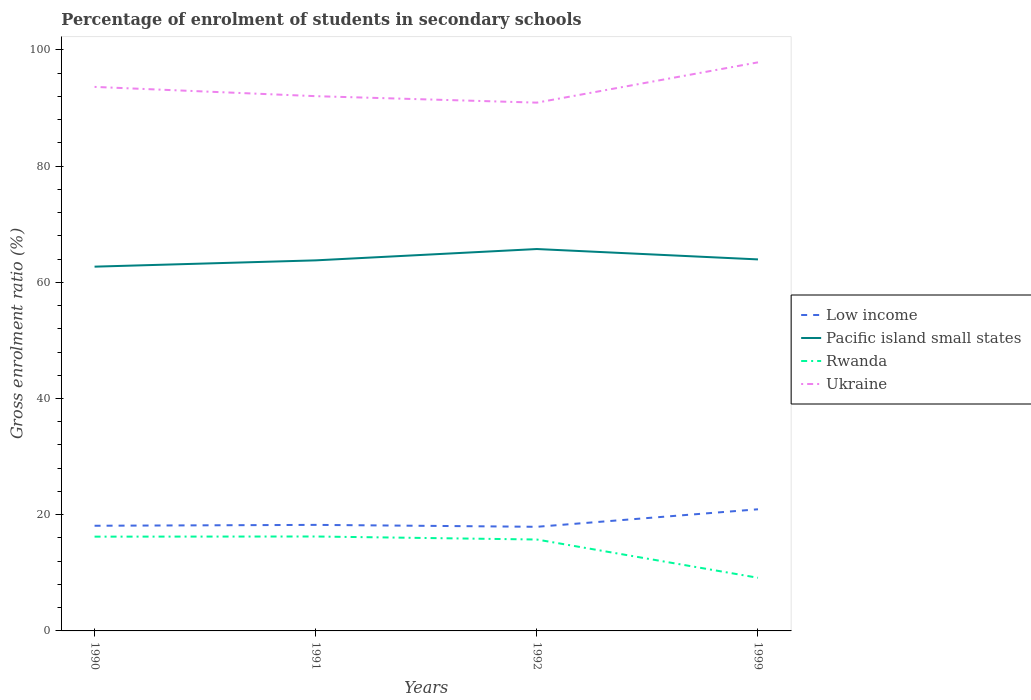How many different coloured lines are there?
Make the answer very short. 4. Does the line corresponding to Rwanda intersect with the line corresponding to Low income?
Provide a succinct answer. No. Is the number of lines equal to the number of legend labels?
Ensure brevity in your answer.  Yes. Across all years, what is the maximum percentage of students enrolled in secondary schools in Rwanda?
Your answer should be compact. 9.15. In which year was the percentage of students enrolled in secondary schools in Low income maximum?
Offer a terse response. 1992. What is the total percentage of students enrolled in secondary schools in Ukraine in the graph?
Keep it short and to the point. -5.82. What is the difference between the highest and the second highest percentage of students enrolled in secondary schools in Low income?
Offer a terse response. 3.02. How many lines are there?
Offer a very short reply. 4. Are the values on the major ticks of Y-axis written in scientific E-notation?
Ensure brevity in your answer.  No. Does the graph contain any zero values?
Your answer should be very brief. No. Does the graph contain grids?
Ensure brevity in your answer.  No. Where does the legend appear in the graph?
Keep it short and to the point. Center right. How many legend labels are there?
Make the answer very short. 4. What is the title of the graph?
Give a very brief answer. Percentage of enrolment of students in secondary schools. Does "Venezuela" appear as one of the legend labels in the graph?
Provide a succinct answer. No. What is the label or title of the Y-axis?
Give a very brief answer. Gross enrolment ratio (%). What is the Gross enrolment ratio (%) in Low income in 1990?
Keep it short and to the point. 18.1. What is the Gross enrolment ratio (%) in Pacific island small states in 1990?
Provide a succinct answer. 62.69. What is the Gross enrolment ratio (%) in Rwanda in 1990?
Make the answer very short. 16.23. What is the Gross enrolment ratio (%) in Ukraine in 1990?
Your answer should be compact. 93.63. What is the Gross enrolment ratio (%) of Low income in 1991?
Make the answer very short. 18.25. What is the Gross enrolment ratio (%) in Pacific island small states in 1991?
Give a very brief answer. 63.78. What is the Gross enrolment ratio (%) in Rwanda in 1991?
Provide a short and direct response. 16.25. What is the Gross enrolment ratio (%) of Ukraine in 1991?
Your answer should be very brief. 92.04. What is the Gross enrolment ratio (%) in Low income in 1992?
Your answer should be compact. 17.92. What is the Gross enrolment ratio (%) of Pacific island small states in 1992?
Your response must be concise. 65.73. What is the Gross enrolment ratio (%) in Rwanda in 1992?
Give a very brief answer. 15.73. What is the Gross enrolment ratio (%) in Ukraine in 1992?
Ensure brevity in your answer.  90.92. What is the Gross enrolment ratio (%) in Low income in 1999?
Ensure brevity in your answer.  20.94. What is the Gross enrolment ratio (%) of Pacific island small states in 1999?
Offer a terse response. 63.94. What is the Gross enrolment ratio (%) in Rwanda in 1999?
Your response must be concise. 9.15. What is the Gross enrolment ratio (%) in Ukraine in 1999?
Make the answer very short. 97.86. Across all years, what is the maximum Gross enrolment ratio (%) of Low income?
Your response must be concise. 20.94. Across all years, what is the maximum Gross enrolment ratio (%) of Pacific island small states?
Your response must be concise. 65.73. Across all years, what is the maximum Gross enrolment ratio (%) of Rwanda?
Your response must be concise. 16.25. Across all years, what is the maximum Gross enrolment ratio (%) in Ukraine?
Offer a terse response. 97.86. Across all years, what is the minimum Gross enrolment ratio (%) in Low income?
Your response must be concise. 17.92. Across all years, what is the minimum Gross enrolment ratio (%) of Pacific island small states?
Your response must be concise. 62.69. Across all years, what is the minimum Gross enrolment ratio (%) of Rwanda?
Your answer should be very brief. 9.15. Across all years, what is the minimum Gross enrolment ratio (%) in Ukraine?
Your answer should be compact. 90.92. What is the total Gross enrolment ratio (%) of Low income in the graph?
Your response must be concise. 75.21. What is the total Gross enrolment ratio (%) in Pacific island small states in the graph?
Make the answer very short. 256.14. What is the total Gross enrolment ratio (%) of Rwanda in the graph?
Offer a terse response. 57.36. What is the total Gross enrolment ratio (%) in Ukraine in the graph?
Your answer should be very brief. 374.45. What is the difference between the Gross enrolment ratio (%) in Low income in 1990 and that in 1991?
Your response must be concise. -0.15. What is the difference between the Gross enrolment ratio (%) in Pacific island small states in 1990 and that in 1991?
Offer a terse response. -1.08. What is the difference between the Gross enrolment ratio (%) of Rwanda in 1990 and that in 1991?
Your response must be concise. -0.03. What is the difference between the Gross enrolment ratio (%) in Ukraine in 1990 and that in 1991?
Give a very brief answer. 1.6. What is the difference between the Gross enrolment ratio (%) of Low income in 1990 and that in 1992?
Your answer should be very brief. 0.18. What is the difference between the Gross enrolment ratio (%) of Pacific island small states in 1990 and that in 1992?
Ensure brevity in your answer.  -3.03. What is the difference between the Gross enrolment ratio (%) in Rwanda in 1990 and that in 1992?
Give a very brief answer. 0.49. What is the difference between the Gross enrolment ratio (%) of Ukraine in 1990 and that in 1992?
Keep it short and to the point. 2.71. What is the difference between the Gross enrolment ratio (%) in Low income in 1990 and that in 1999?
Ensure brevity in your answer.  -2.84. What is the difference between the Gross enrolment ratio (%) of Pacific island small states in 1990 and that in 1999?
Make the answer very short. -1.25. What is the difference between the Gross enrolment ratio (%) of Rwanda in 1990 and that in 1999?
Ensure brevity in your answer.  7.08. What is the difference between the Gross enrolment ratio (%) in Ukraine in 1990 and that in 1999?
Your answer should be compact. -4.22. What is the difference between the Gross enrolment ratio (%) in Low income in 1991 and that in 1992?
Provide a succinct answer. 0.33. What is the difference between the Gross enrolment ratio (%) of Pacific island small states in 1991 and that in 1992?
Give a very brief answer. -1.95. What is the difference between the Gross enrolment ratio (%) in Rwanda in 1991 and that in 1992?
Your answer should be very brief. 0.52. What is the difference between the Gross enrolment ratio (%) of Ukraine in 1991 and that in 1992?
Provide a short and direct response. 1.11. What is the difference between the Gross enrolment ratio (%) of Low income in 1991 and that in 1999?
Offer a terse response. -2.69. What is the difference between the Gross enrolment ratio (%) in Pacific island small states in 1991 and that in 1999?
Offer a very short reply. -0.17. What is the difference between the Gross enrolment ratio (%) of Rwanda in 1991 and that in 1999?
Provide a succinct answer. 7.11. What is the difference between the Gross enrolment ratio (%) in Ukraine in 1991 and that in 1999?
Provide a succinct answer. -5.82. What is the difference between the Gross enrolment ratio (%) of Low income in 1992 and that in 1999?
Your answer should be compact. -3.02. What is the difference between the Gross enrolment ratio (%) of Pacific island small states in 1992 and that in 1999?
Offer a very short reply. 1.78. What is the difference between the Gross enrolment ratio (%) in Rwanda in 1992 and that in 1999?
Provide a short and direct response. 6.58. What is the difference between the Gross enrolment ratio (%) of Ukraine in 1992 and that in 1999?
Offer a terse response. -6.93. What is the difference between the Gross enrolment ratio (%) of Low income in 1990 and the Gross enrolment ratio (%) of Pacific island small states in 1991?
Ensure brevity in your answer.  -45.68. What is the difference between the Gross enrolment ratio (%) in Low income in 1990 and the Gross enrolment ratio (%) in Rwanda in 1991?
Offer a very short reply. 1.85. What is the difference between the Gross enrolment ratio (%) in Low income in 1990 and the Gross enrolment ratio (%) in Ukraine in 1991?
Keep it short and to the point. -73.94. What is the difference between the Gross enrolment ratio (%) of Pacific island small states in 1990 and the Gross enrolment ratio (%) of Rwanda in 1991?
Give a very brief answer. 46.44. What is the difference between the Gross enrolment ratio (%) in Pacific island small states in 1990 and the Gross enrolment ratio (%) in Ukraine in 1991?
Provide a succinct answer. -29.34. What is the difference between the Gross enrolment ratio (%) in Rwanda in 1990 and the Gross enrolment ratio (%) in Ukraine in 1991?
Make the answer very short. -75.81. What is the difference between the Gross enrolment ratio (%) of Low income in 1990 and the Gross enrolment ratio (%) of Pacific island small states in 1992?
Your response must be concise. -47.63. What is the difference between the Gross enrolment ratio (%) in Low income in 1990 and the Gross enrolment ratio (%) in Rwanda in 1992?
Give a very brief answer. 2.37. What is the difference between the Gross enrolment ratio (%) in Low income in 1990 and the Gross enrolment ratio (%) in Ukraine in 1992?
Make the answer very short. -72.82. What is the difference between the Gross enrolment ratio (%) of Pacific island small states in 1990 and the Gross enrolment ratio (%) of Rwanda in 1992?
Keep it short and to the point. 46.96. What is the difference between the Gross enrolment ratio (%) of Pacific island small states in 1990 and the Gross enrolment ratio (%) of Ukraine in 1992?
Keep it short and to the point. -28.23. What is the difference between the Gross enrolment ratio (%) in Rwanda in 1990 and the Gross enrolment ratio (%) in Ukraine in 1992?
Your answer should be compact. -74.7. What is the difference between the Gross enrolment ratio (%) in Low income in 1990 and the Gross enrolment ratio (%) in Pacific island small states in 1999?
Keep it short and to the point. -45.84. What is the difference between the Gross enrolment ratio (%) in Low income in 1990 and the Gross enrolment ratio (%) in Rwanda in 1999?
Your response must be concise. 8.95. What is the difference between the Gross enrolment ratio (%) in Low income in 1990 and the Gross enrolment ratio (%) in Ukraine in 1999?
Keep it short and to the point. -79.76. What is the difference between the Gross enrolment ratio (%) of Pacific island small states in 1990 and the Gross enrolment ratio (%) of Rwanda in 1999?
Your answer should be very brief. 53.55. What is the difference between the Gross enrolment ratio (%) in Pacific island small states in 1990 and the Gross enrolment ratio (%) in Ukraine in 1999?
Give a very brief answer. -35.16. What is the difference between the Gross enrolment ratio (%) in Rwanda in 1990 and the Gross enrolment ratio (%) in Ukraine in 1999?
Provide a short and direct response. -81.63. What is the difference between the Gross enrolment ratio (%) of Low income in 1991 and the Gross enrolment ratio (%) of Pacific island small states in 1992?
Give a very brief answer. -47.48. What is the difference between the Gross enrolment ratio (%) in Low income in 1991 and the Gross enrolment ratio (%) in Rwanda in 1992?
Keep it short and to the point. 2.52. What is the difference between the Gross enrolment ratio (%) of Low income in 1991 and the Gross enrolment ratio (%) of Ukraine in 1992?
Offer a terse response. -72.67. What is the difference between the Gross enrolment ratio (%) in Pacific island small states in 1991 and the Gross enrolment ratio (%) in Rwanda in 1992?
Provide a succinct answer. 48.05. What is the difference between the Gross enrolment ratio (%) of Pacific island small states in 1991 and the Gross enrolment ratio (%) of Ukraine in 1992?
Your answer should be very brief. -27.15. What is the difference between the Gross enrolment ratio (%) of Rwanda in 1991 and the Gross enrolment ratio (%) of Ukraine in 1992?
Provide a short and direct response. -74.67. What is the difference between the Gross enrolment ratio (%) of Low income in 1991 and the Gross enrolment ratio (%) of Pacific island small states in 1999?
Make the answer very short. -45.69. What is the difference between the Gross enrolment ratio (%) in Low income in 1991 and the Gross enrolment ratio (%) in Rwanda in 1999?
Make the answer very short. 9.1. What is the difference between the Gross enrolment ratio (%) in Low income in 1991 and the Gross enrolment ratio (%) in Ukraine in 1999?
Provide a short and direct response. -79.61. What is the difference between the Gross enrolment ratio (%) in Pacific island small states in 1991 and the Gross enrolment ratio (%) in Rwanda in 1999?
Provide a succinct answer. 54.63. What is the difference between the Gross enrolment ratio (%) of Pacific island small states in 1991 and the Gross enrolment ratio (%) of Ukraine in 1999?
Ensure brevity in your answer.  -34.08. What is the difference between the Gross enrolment ratio (%) in Rwanda in 1991 and the Gross enrolment ratio (%) in Ukraine in 1999?
Your answer should be very brief. -81.6. What is the difference between the Gross enrolment ratio (%) in Low income in 1992 and the Gross enrolment ratio (%) in Pacific island small states in 1999?
Keep it short and to the point. -46.02. What is the difference between the Gross enrolment ratio (%) in Low income in 1992 and the Gross enrolment ratio (%) in Rwanda in 1999?
Provide a succinct answer. 8.77. What is the difference between the Gross enrolment ratio (%) in Low income in 1992 and the Gross enrolment ratio (%) in Ukraine in 1999?
Offer a very short reply. -79.94. What is the difference between the Gross enrolment ratio (%) in Pacific island small states in 1992 and the Gross enrolment ratio (%) in Rwanda in 1999?
Provide a short and direct response. 56.58. What is the difference between the Gross enrolment ratio (%) in Pacific island small states in 1992 and the Gross enrolment ratio (%) in Ukraine in 1999?
Offer a very short reply. -32.13. What is the difference between the Gross enrolment ratio (%) in Rwanda in 1992 and the Gross enrolment ratio (%) in Ukraine in 1999?
Your answer should be compact. -82.13. What is the average Gross enrolment ratio (%) of Low income per year?
Keep it short and to the point. 18.8. What is the average Gross enrolment ratio (%) in Pacific island small states per year?
Provide a succinct answer. 64.03. What is the average Gross enrolment ratio (%) in Rwanda per year?
Your response must be concise. 14.34. What is the average Gross enrolment ratio (%) in Ukraine per year?
Your response must be concise. 93.61. In the year 1990, what is the difference between the Gross enrolment ratio (%) in Low income and Gross enrolment ratio (%) in Pacific island small states?
Ensure brevity in your answer.  -44.59. In the year 1990, what is the difference between the Gross enrolment ratio (%) in Low income and Gross enrolment ratio (%) in Rwanda?
Ensure brevity in your answer.  1.88. In the year 1990, what is the difference between the Gross enrolment ratio (%) in Low income and Gross enrolment ratio (%) in Ukraine?
Your response must be concise. -75.53. In the year 1990, what is the difference between the Gross enrolment ratio (%) of Pacific island small states and Gross enrolment ratio (%) of Rwanda?
Give a very brief answer. 46.47. In the year 1990, what is the difference between the Gross enrolment ratio (%) of Pacific island small states and Gross enrolment ratio (%) of Ukraine?
Ensure brevity in your answer.  -30.94. In the year 1990, what is the difference between the Gross enrolment ratio (%) of Rwanda and Gross enrolment ratio (%) of Ukraine?
Offer a very short reply. -77.41. In the year 1991, what is the difference between the Gross enrolment ratio (%) of Low income and Gross enrolment ratio (%) of Pacific island small states?
Provide a succinct answer. -45.53. In the year 1991, what is the difference between the Gross enrolment ratio (%) in Low income and Gross enrolment ratio (%) in Rwanda?
Your response must be concise. 2. In the year 1991, what is the difference between the Gross enrolment ratio (%) in Low income and Gross enrolment ratio (%) in Ukraine?
Your answer should be very brief. -73.79. In the year 1991, what is the difference between the Gross enrolment ratio (%) in Pacific island small states and Gross enrolment ratio (%) in Rwanda?
Give a very brief answer. 47.52. In the year 1991, what is the difference between the Gross enrolment ratio (%) in Pacific island small states and Gross enrolment ratio (%) in Ukraine?
Your answer should be compact. -28.26. In the year 1991, what is the difference between the Gross enrolment ratio (%) of Rwanda and Gross enrolment ratio (%) of Ukraine?
Keep it short and to the point. -75.78. In the year 1992, what is the difference between the Gross enrolment ratio (%) in Low income and Gross enrolment ratio (%) in Pacific island small states?
Make the answer very short. -47.81. In the year 1992, what is the difference between the Gross enrolment ratio (%) in Low income and Gross enrolment ratio (%) in Rwanda?
Keep it short and to the point. 2.19. In the year 1992, what is the difference between the Gross enrolment ratio (%) of Low income and Gross enrolment ratio (%) of Ukraine?
Offer a very short reply. -73. In the year 1992, what is the difference between the Gross enrolment ratio (%) in Pacific island small states and Gross enrolment ratio (%) in Rwanda?
Offer a very short reply. 50. In the year 1992, what is the difference between the Gross enrolment ratio (%) of Pacific island small states and Gross enrolment ratio (%) of Ukraine?
Your answer should be compact. -25.2. In the year 1992, what is the difference between the Gross enrolment ratio (%) of Rwanda and Gross enrolment ratio (%) of Ukraine?
Give a very brief answer. -75.19. In the year 1999, what is the difference between the Gross enrolment ratio (%) in Low income and Gross enrolment ratio (%) in Pacific island small states?
Offer a very short reply. -43.01. In the year 1999, what is the difference between the Gross enrolment ratio (%) of Low income and Gross enrolment ratio (%) of Rwanda?
Your answer should be very brief. 11.79. In the year 1999, what is the difference between the Gross enrolment ratio (%) of Low income and Gross enrolment ratio (%) of Ukraine?
Provide a succinct answer. -76.92. In the year 1999, what is the difference between the Gross enrolment ratio (%) in Pacific island small states and Gross enrolment ratio (%) in Rwanda?
Your answer should be compact. 54.8. In the year 1999, what is the difference between the Gross enrolment ratio (%) of Pacific island small states and Gross enrolment ratio (%) of Ukraine?
Offer a terse response. -33.91. In the year 1999, what is the difference between the Gross enrolment ratio (%) in Rwanda and Gross enrolment ratio (%) in Ukraine?
Offer a very short reply. -88.71. What is the ratio of the Gross enrolment ratio (%) in Rwanda in 1990 to that in 1991?
Ensure brevity in your answer.  1. What is the ratio of the Gross enrolment ratio (%) in Ukraine in 1990 to that in 1991?
Your answer should be compact. 1.02. What is the ratio of the Gross enrolment ratio (%) of Low income in 1990 to that in 1992?
Provide a succinct answer. 1.01. What is the ratio of the Gross enrolment ratio (%) in Pacific island small states in 1990 to that in 1992?
Offer a very short reply. 0.95. What is the ratio of the Gross enrolment ratio (%) in Rwanda in 1990 to that in 1992?
Your answer should be very brief. 1.03. What is the ratio of the Gross enrolment ratio (%) of Ukraine in 1990 to that in 1992?
Your answer should be compact. 1.03. What is the ratio of the Gross enrolment ratio (%) of Low income in 1990 to that in 1999?
Offer a very short reply. 0.86. What is the ratio of the Gross enrolment ratio (%) of Pacific island small states in 1990 to that in 1999?
Provide a succinct answer. 0.98. What is the ratio of the Gross enrolment ratio (%) of Rwanda in 1990 to that in 1999?
Make the answer very short. 1.77. What is the ratio of the Gross enrolment ratio (%) of Ukraine in 1990 to that in 1999?
Offer a terse response. 0.96. What is the ratio of the Gross enrolment ratio (%) of Low income in 1991 to that in 1992?
Make the answer very short. 1.02. What is the ratio of the Gross enrolment ratio (%) in Pacific island small states in 1991 to that in 1992?
Your answer should be very brief. 0.97. What is the ratio of the Gross enrolment ratio (%) of Rwanda in 1991 to that in 1992?
Give a very brief answer. 1.03. What is the ratio of the Gross enrolment ratio (%) in Ukraine in 1991 to that in 1992?
Ensure brevity in your answer.  1.01. What is the ratio of the Gross enrolment ratio (%) in Low income in 1991 to that in 1999?
Keep it short and to the point. 0.87. What is the ratio of the Gross enrolment ratio (%) of Pacific island small states in 1991 to that in 1999?
Your answer should be compact. 1. What is the ratio of the Gross enrolment ratio (%) of Rwanda in 1991 to that in 1999?
Make the answer very short. 1.78. What is the ratio of the Gross enrolment ratio (%) in Ukraine in 1991 to that in 1999?
Your response must be concise. 0.94. What is the ratio of the Gross enrolment ratio (%) in Low income in 1992 to that in 1999?
Keep it short and to the point. 0.86. What is the ratio of the Gross enrolment ratio (%) of Pacific island small states in 1992 to that in 1999?
Offer a terse response. 1.03. What is the ratio of the Gross enrolment ratio (%) in Rwanda in 1992 to that in 1999?
Provide a short and direct response. 1.72. What is the ratio of the Gross enrolment ratio (%) in Ukraine in 1992 to that in 1999?
Your answer should be very brief. 0.93. What is the difference between the highest and the second highest Gross enrolment ratio (%) of Low income?
Provide a succinct answer. 2.69. What is the difference between the highest and the second highest Gross enrolment ratio (%) of Pacific island small states?
Keep it short and to the point. 1.78. What is the difference between the highest and the second highest Gross enrolment ratio (%) of Rwanda?
Keep it short and to the point. 0.03. What is the difference between the highest and the second highest Gross enrolment ratio (%) in Ukraine?
Provide a short and direct response. 4.22. What is the difference between the highest and the lowest Gross enrolment ratio (%) in Low income?
Provide a succinct answer. 3.02. What is the difference between the highest and the lowest Gross enrolment ratio (%) of Pacific island small states?
Offer a terse response. 3.03. What is the difference between the highest and the lowest Gross enrolment ratio (%) of Rwanda?
Offer a very short reply. 7.11. What is the difference between the highest and the lowest Gross enrolment ratio (%) in Ukraine?
Give a very brief answer. 6.93. 